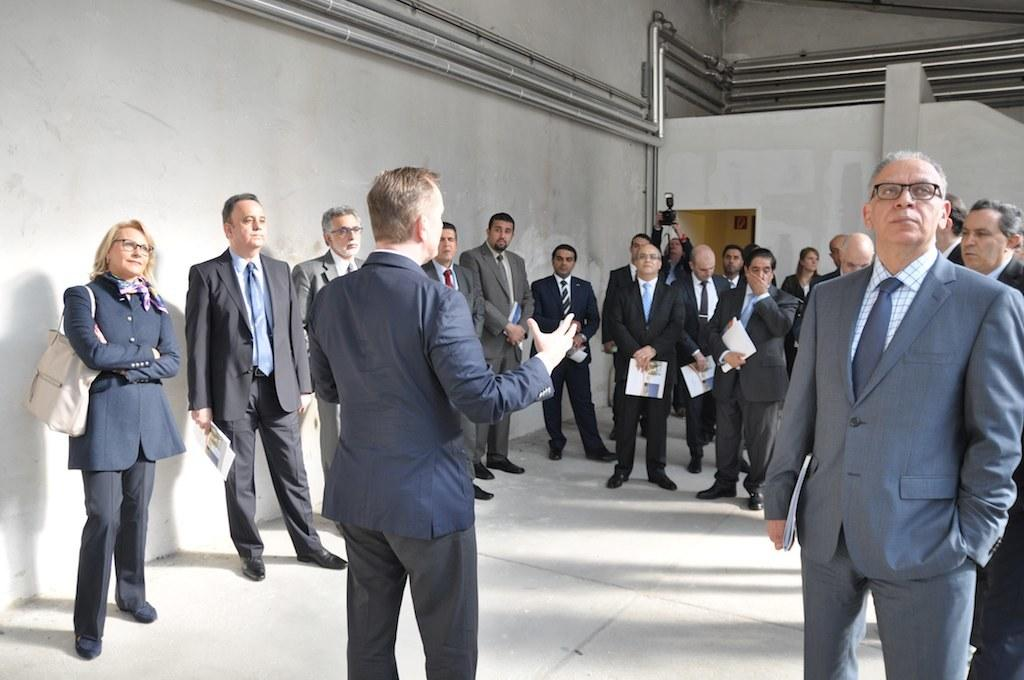What can be seen in the image? There is a group of people in the image. Can you describe the people in the group? Some people in the group are wearing spectacles, and some are holding papers. What is visible in the background of the image? There are pipes on the wall in the background of the image. How many pigs are visible in the image? There are no pigs present in the image. What type of credit is being discussed among the people in the image? There is no indication of any credit-related discussion in the image. 